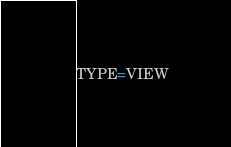<code> <loc_0><loc_0><loc_500><loc_500><_VisualBasic_>TYPE=VIEW</code> 